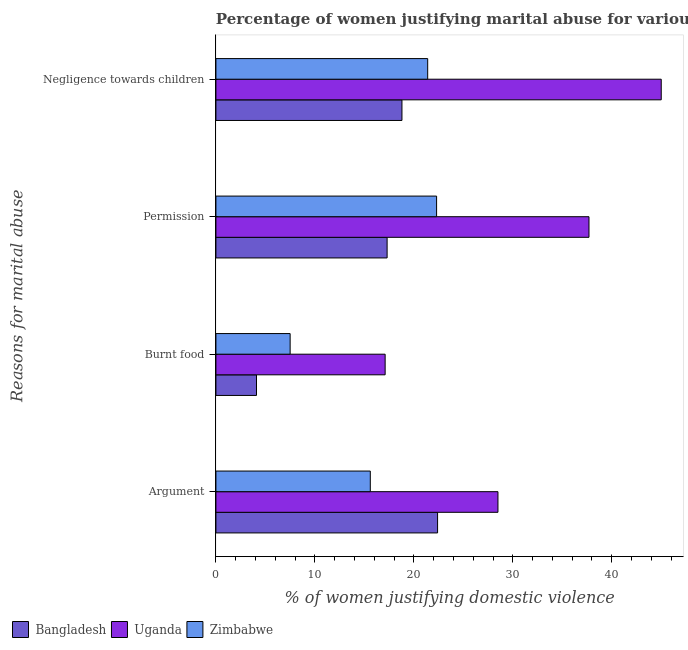How many different coloured bars are there?
Make the answer very short. 3. Are the number of bars per tick equal to the number of legend labels?
Offer a very short reply. Yes. Are the number of bars on each tick of the Y-axis equal?
Offer a very short reply. Yes. How many bars are there on the 3rd tick from the top?
Your answer should be compact. 3. What is the label of the 1st group of bars from the top?
Give a very brief answer. Negligence towards children. Across all countries, what is the maximum percentage of women justifying abuse in the case of an argument?
Ensure brevity in your answer.  28.5. In which country was the percentage of women justifying abuse in the case of an argument maximum?
Offer a terse response. Uganda. What is the total percentage of women justifying abuse for burning food in the graph?
Your answer should be very brief. 28.7. What is the difference between the percentage of women justifying abuse for going without permission in Bangladesh and the percentage of women justifying abuse in the case of an argument in Zimbabwe?
Your answer should be compact. 1.7. What is the average percentage of women justifying abuse in the case of an argument per country?
Your response must be concise. 22.17. In how many countries, is the percentage of women justifying abuse for going without permission greater than 40 %?
Your response must be concise. 0. What is the ratio of the percentage of women justifying abuse for showing negligence towards children in Bangladesh to that in Uganda?
Make the answer very short. 0.42. What is the difference between the highest and the second highest percentage of women justifying abuse for showing negligence towards children?
Provide a succinct answer. 23.6. What is the difference between the highest and the lowest percentage of women justifying abuse for showing negligence towards children?
Offer a very short reply. 26.2. Is the sum of the percentage of women justifying abuse for burning food in Uganda and Bangladesh greater than the maximum percentage of women justifying abuse in the case of an argument across all countries?
Ensure brevity in your answer.  No. Is it the case that in every country, the sum of the percentage of women justifying abuse for burning food and percentage of women justifying abuse for going without permission is greater than the sum of percentage of women justifying abuse in the case of an argument and percentage of women justifying abuse for showing negligence towards children?
Provide a succinct answer. No. What does the 1st bar from the top in Argument represents?
Your response must be concise. Zimbabwe. What does the 2nd bar from the bottom in Argument represents?
Ensure brevity in your answer.  Uganda. Is it the case that in every country, the sum of the percentage of women justifying abuse in the case of an argument and percentage of women justifying abuse for burning food is greater than the percentage of women justifying abuse for going without permission?
Your answer should be compact. Yes. Are all the bars in the graph horizontal?
Your answer should be very brief. Yes. How many countries are there in the graph?
Provide a short and direct response. 3. Are the values on the major ticks of X-axis written in scientific E-notation?
Make the answer very short. No. Where does the legend appear in the graph?
Give a very brief answer. Bottom left. What is the title of the graph?
Your answer should be compact. Percentage of women justifying marital abuse for various reasons in the survey of 2011. What is the label or title of the X-axis?
Provide a short and direct response. % of women justifying domestic violence. What is the label or title of the Y-axis?
Provide a succinct answer. Reasons for marital abuse. What is the % of women justifying domestic violence of Bangladesh in Argument?
Make the answer very short. 22.4. What is the % of women justifying domestic violence in Zimbabwe in Argument?
Provide a short and direct response. 15.6. What is the % of women justifying domestic violence of Bangladesh in Burnt food?
Your answer should be very brief. 4.1. What is the % of women justifying domestic violence in Uganda in Burnt food?
Ensure brevity in your answer.  17.1. What is the % of women justifying domestic violence of Uganda in Permission?
Give a very brief answer. 37.7. What is the % of women justifying domestic violence of Zimbabwe in Permission?
Provide a short and direct response. 22.3. What is the % of women justifying domestic violence of Zimbabwe in Negligence towards children?
Ensure brevity in your answer.  21.4. Across all Reasons for marital abuse, what is the maximum % of women justifying domestic violence in Bangladesh?
Your answer should be very brief. 22.4. Across all Reasons for marital abuse, what is the maximum % of women justifying domestic violence in Uganda?
Provide a succinct answer. 45. Across all Reasons for marital abuse, what is the maximum % of women justifying domestic violence of Zimbabwe?
Your answer should be very brief. 22.3. Across all Reasons for marital abuse, what is the minimum % of women justifying domestic violence in Uganda?
Your answer should be compact. 17.1. What is the total % of women justifying domestic violence of Bangladesh in the graph?
Give a very brief answer. 62.6. What is the total % of women justifying domestic violence of Uganda in the graph?
Your answer should be compact. 128.3. What is the total % of women justifying domestic violence of Zimbabwe in the graph?
Provide a short and direct response. 66.8. What is the difference between the % of women justifying domestic violence of Bangladesh in Argument and that in Burnt food?
Keep it short and to the point. 18.3. What is the difference between the % of women justifying domestic violence of Zimbabwe in Argument and that in Burnt food?
Your response must be concise. 8.1. What is the difference between the % of women justifying domestic violence of Bangladesh in Argument and that in Permission?
Ensure brevity in your answer.  5.1. What is the difference between the % of women justifying domestic violence of Uganda in Argument and that in Permission?
Provide a succinct answer. -9.2. What is the difference between the % of women justifying domestic violence of Zimbabwe in Argument and that in Permission?
Provide a short and direct response. -6.7. What is the difference between the % of women justifying domestic violence of Uganda in Argument and that in Negligence towards children?
Provide a succinct answer. -16.5. What is the difference between the % of women justifying domestic violence in Uganda in Burnt food and that in Permission?
Your answer should be very brief. -20.6. What is the difference between the % of women justifying domestic violence in Zimbabwe in Burnt food and that in Permission?
Keep it short and to the point. -14.8. What is the difference between the % of women justifying domestic violence of Bangladesh in Burnt food and that in Negligence towards children?
Your answer should be compact. -14.7. What is the difference between the % of women justifying domestic violence in Uganda in Burnt food and that in Negligence towards children?
Keep it short and to the point. -27.9. What is the difference between the % of women justifying domestic violence of Bangladesh in Permission and that in Negligence towards children?
Provide a succinct answer. -1.5. What is the difference between the % of women justifying domestic violence of Zimbabwe in Permission and that in Negligence towards children?
Your answer should be compact. 0.9. What is the difference between the % of women justifying domestic violence of Bangladesh in Argument and the % of women justifying domestic violence of Uganda in Burnt food?
Your answer should be compact. 5.3. What is the difference between the % of women justifying domestic violence of Uganda in Argument and the % of women justifying domestic violence of Zimbabwe in Burnt food?
Offer a very short reply. 21. What is the difference between the % of women justifying domestic violence of Bangladesh in Argument and the % of women justifying domestic violence of Uganda in Permission?
Give a very brief answer. -15.3. What is the difference between the % of women justifying domestic violence in Bangladesh in Argument and the % of women justifying domestic violence in Zimbabwe in Permission?
Provide a short and direct response. 0.1. What is the difference between the % of women justifying domestic violence in Uganda in Argument and the % of women justifying domestic violence in Zimbabwe in Permission?
Ensure brevity in your answer.  6.2. What is the difference between the % of women justifying domestic violence of Bangladesh in Argument and the % of women justifying domestic violence of Uganda in Negligence towards children?
Your answer should be compact. -22.6. What is the difference between the % of women justifying domestic violence of Bangladesh in Burnt food and the % of women justifying domestic violence of Uganda in Permission?
Your answer should be compact. -33.6. What is the difference between the % of women justifying domestic violence of Bangladesh in Burnt food and the % of women justifying domestic violence of Zimbabwe in Permission?
Make the answer very short. -18.2. What is the difference between the % of women justifying domestic violence in Uganda in Burnt food and the % of women justifying domestic violence in Zimbabwe in Permission?
Your answer should be very brief. -5.2. What is the difference between the % of women justifying domestic violence in Bangladesh in Burnt food and the % of women justifying domestic violence in Uganda in Negligence towards children?
Offer a terse response. -40.9. What is the difference between the % of women justifying domestic violence of Bangladesh in Burnt food and the % of women justifying domestic violence of Zimbabwe in Negligence towards children?
Offer a terse response. -17.3. What is the difference between the % of women justifying domestic violence of Uganda in Burnt food and the % of women justifying domestic violence of Zimbabwe in Negligence towards children?
Your response must be concise. -4.3. What is the difference between the % of women justifying domestic violence in Bangladesh in Permission and the % of women justifying domestic violence in Uganda in Negligence towards children?
Your answer should be very brief. -27.7. What is the difference between the % of women justifying domestic violence in Bangladesh in Permission and the % of women justifying domestic violence in Zimbabwe in Negligence towards children?
Give a very brief answer. -4.1. What is the difference between the % of women justifying domestic violence of Uganda in Permission and the % of women justifying domestic violence of Zimbabwe in Negligence towards children?
Your response must be concise. 16.3. What is the average % of women justifying domestic violence of Bangladesh per Reasons for marital abuse?
Your response must be concise. 15.65. What is the average % of women justifying domestic violence of Uganda per Reasons for marital abuse?
Offer a terse response. 32.08. What is the average % of women justifying domestic violence in Zimbabwe per Reasons for marital abuse?
Provide a short and direct response. 16.7. What is the difference between the % of women justifying domestic violence of Bangladesh and % of women justifying domestic violence of Uganda in Burnt food?
Your answer should be compact. -13. What is the difference between the % of women justifying domestic violence of Bangladesh and % of women justifying domestic violence of Uganda in Permission?
Provide a succinct answer. -20.4. What is the difference between the % of women justifying domestic violence of Bangladesh and % of women justifying domestic violence of Zimbabwe in Permission?
Your answer should be compact. -5. What is the difference between the % of women justifying domestic violence in Bangladesh and % of women justifying domestic violence in Uganda in Negligence towards children?
Provide a succinct answer. -26.2. What is the difference between the % of women justifying domestic violence of Uganda and % of women justifying domestic violence of Zimbabwe in Negligence towards children?
Your answer should be very brief. 23.6. What is the ratio of the % of women justifying domestic violence in Bangladesh in Argument to that in Burnt food?
Provide a short and direct response. 5.46. What is the ratio of the % of women justifying domestic violence in Zimbabwe in Argument to that in Burnt food?
Your answer should be very brief. 2.08. What is the ratio of the % of women justifying domestic violence in Bangladesh in Argument to that in Permission?
Your answer should be very brief. 1.29. What is the ratio of the % of women justifying domestic violence in Uganda in Argument to that in Permission?
Your response must be concise. 0.76. What is the ratio of the % of women justifying domestic violence in Zimbabwe in Argument to that in Permission?
Your response must be concise. 0.7. What is the ratio of the % of women justifying domestic violence in Bangladesh in Argument to that in Negligence towards children?
Your answer should be very brief. 1.19. What is the ratio of the % of women justifying domestic violence of Uganda in Argument to that in Negligence towards children?
Give a very brief answer. 0.63. What is the ratio of the % of women justifying domestic violence of Zimbabwe in Argument to that in Negligence towards children?
Keep it short and to the point. 0.73. What is the ratio of the % of women justifying domestic violence of Bangladesh in Burnt food to that in Permission?
Ensure brevity in your answer.  0.24. What is the ratio of the % of women justifying domestic violence of Uganda in Burnt food to that in Permission?
Keep it short and to the point. 0.45. What is the ratio of the % of women justifying domestic violence of Zimbabwe in Burnt food to that in Permission?
Your answer should be compact. 0.34. What is the ratio of the % of women justifying domestic violence of Bangladesh in Burnt food to that in Negligence towards children?
Ensure brevity in your answer.  0.22. What is the ratio of the % of women justifying domestic violence in Uganda in Burnt food to that in Negligence towards children?
Your answer should be compact. 0.38. What is the ratio of the % of women justifying domestic violence in Zimbabwe in Burnt food to that in Negligence towards children?
Offer a terse response. 0.35. What is the ratio of the % of women justifying domestic violence of Bangladesh in Permission to that in Negligence towards children?
Offer a terse response. 0.92. What is the ratio of the % of women justifying domestic violence in Uganda in Permission to that in Negligence towards children?
Ensure brevity in your answer.  0.84. What is the ratio of the % of women justifying domestic violence of Zimbabwe in Permission to that in Negligence towards children?
Offer a terse response. 1.04. What is the difference between the highest and the second highest % of women justifying domestic violence in Uganda?
Ensure brevity in your answer.  7.3. What is the difference between the highest and the lowest % of women justifying domestic violence of Uganda?
Your response must be concise. 27.9. What is the difference between the highest and the lowest % of women justifying domestic violence of Zimbabwe?
Give a very brief answer. 14.8. 